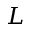<formula> <loc_0><loc_0><loc_500><loc_500>L</formula> 